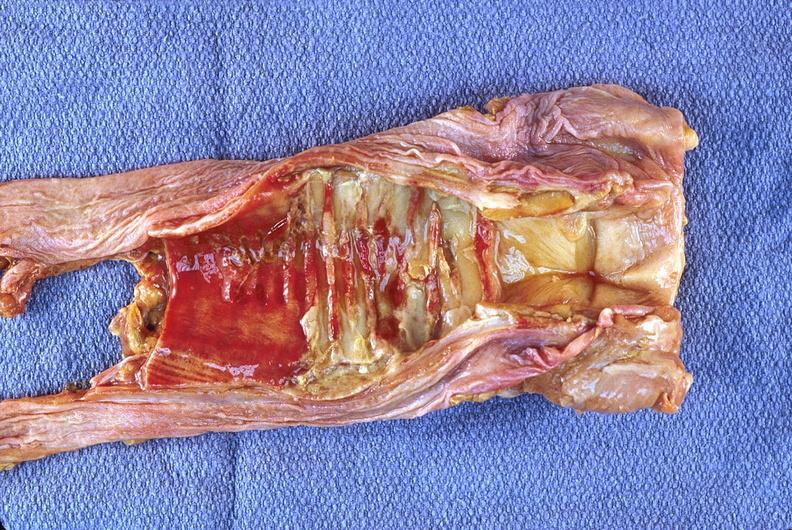s edema present?
Answer the question using a single word or phrase. No 